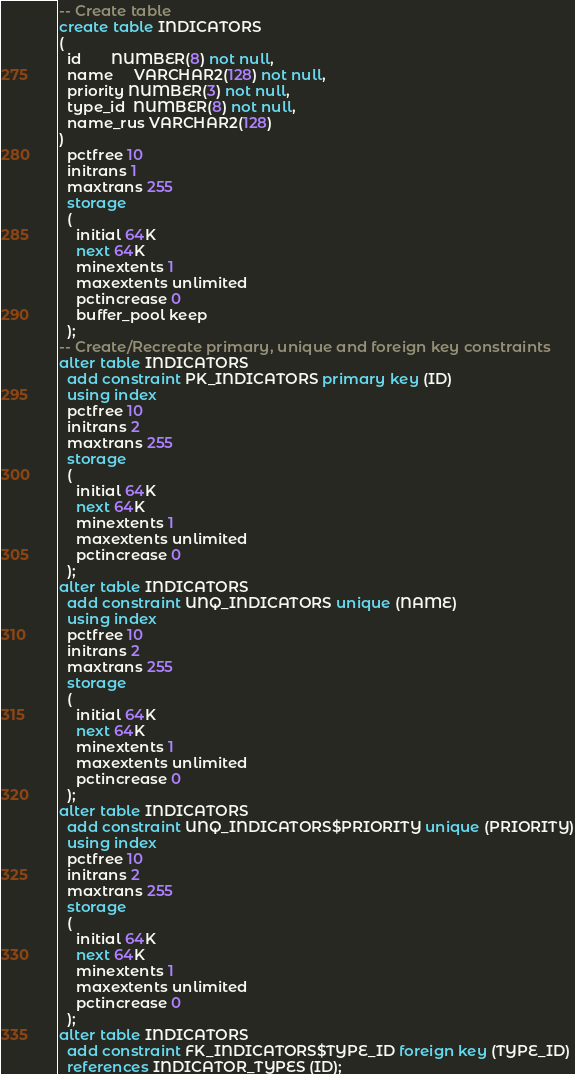<code> <loc_0><loc_0><loc_500><loc_500><_SQL_>-- Create table
create table INDICATORS
(
  id       NUMBER(8) not null,
  name     VARCHAR2(128) not null,
  priority NUMBER(3) not null,
  type_id  NUMBER(8) not null,
  name_rus VARCHAR2(128)
)
  pctfree 10
  initrans 1
  maxtrans 255
  storage
  (
    initial 64K
    next 64K
    minextents 1
    maxextents unlimited
    pctincrease 0
    buffer_pool keep
  );
-- Create/Recreate primary, unique and foreign key constraints 
alter table INDICATORS
  add constraint PK_INDICATORS primary key (ID)
  using index 
  pctfree 10
  initrans 2
  maxtrans 255
  storage
  (
    initial 64K
    next 64K
    minextents 1
    maxextents unlimited
    pctincrease 0
  );
alter table INDICATORS
  add constraint UNQ_INDICATORS unique (NAME)
  using index 
  pctfree 10
  initrans 2
  maxtrans 255
  storage
  (
    initial 64K
    next 64K
    minextents 1
    maxextents unlimited
    pctincrease 0
  );
alter table INDICATORS
  add constraint UNQ_INDICATORS$PRIORITY unique (PRIORITY)
  using index 
  pctfree 10
  initrans 2
  maxtrans 255
  storage
  (
    initial 64K
    next 64K
    minextents 1
    maxextents unlimited
    pctincrease 0
  );
alter table INDICATORS
  add constraint FK_INDICATORS$TYPE_ID foreign key (TYPE_ID)
  references INDICATOR_TYPES (ID);
</code> 